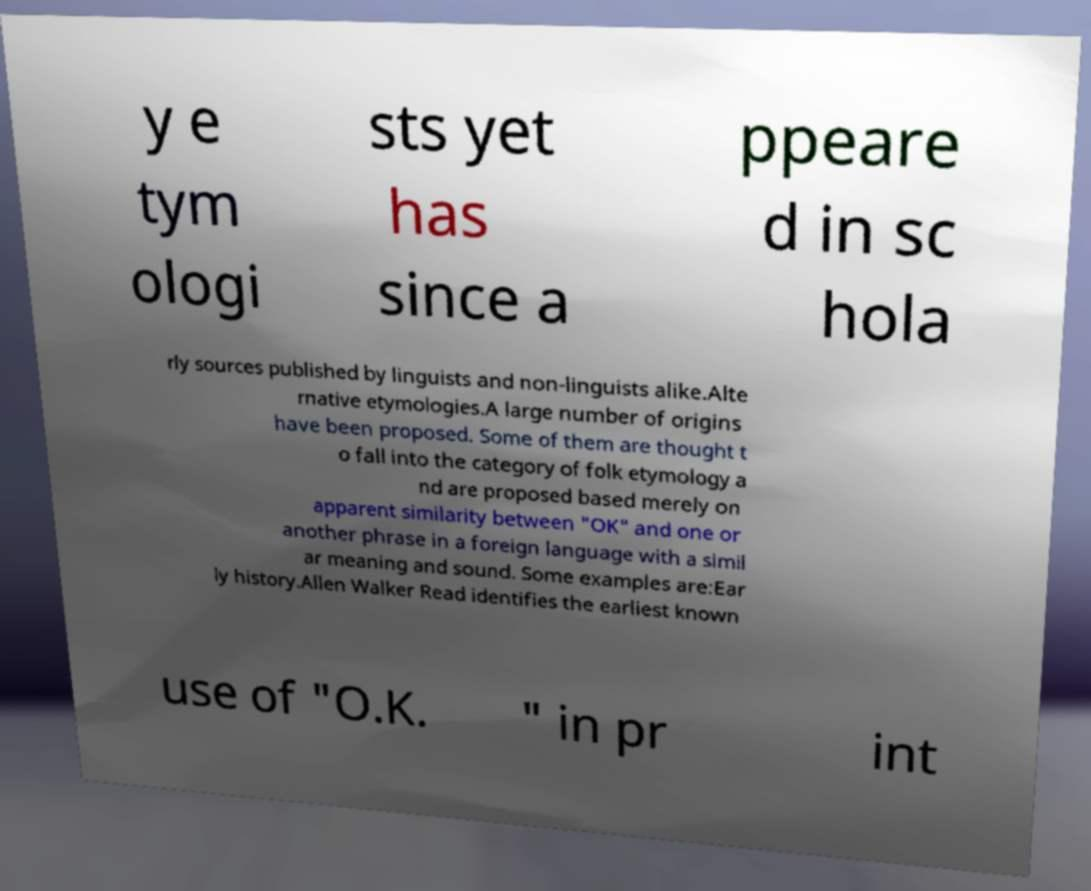I need the written content from this picture converted into text. Can you do that? y e tym ologi sts yet has since a ppeare d in sc hola rly sources published by linguists and non-linguists alike.Alte rnative etymologies.A large number of origins have been proposed. Some of them are thought t o fall into the category of folk etymology a nd are proposed based merely on apparent similarity between "OK" and one or another phrase in a foreign language with a simil ar meaning and sound. Some examples are:Ear ly history.Allen Walker Read identifies the earliest known use of "O.K. " in pr int 